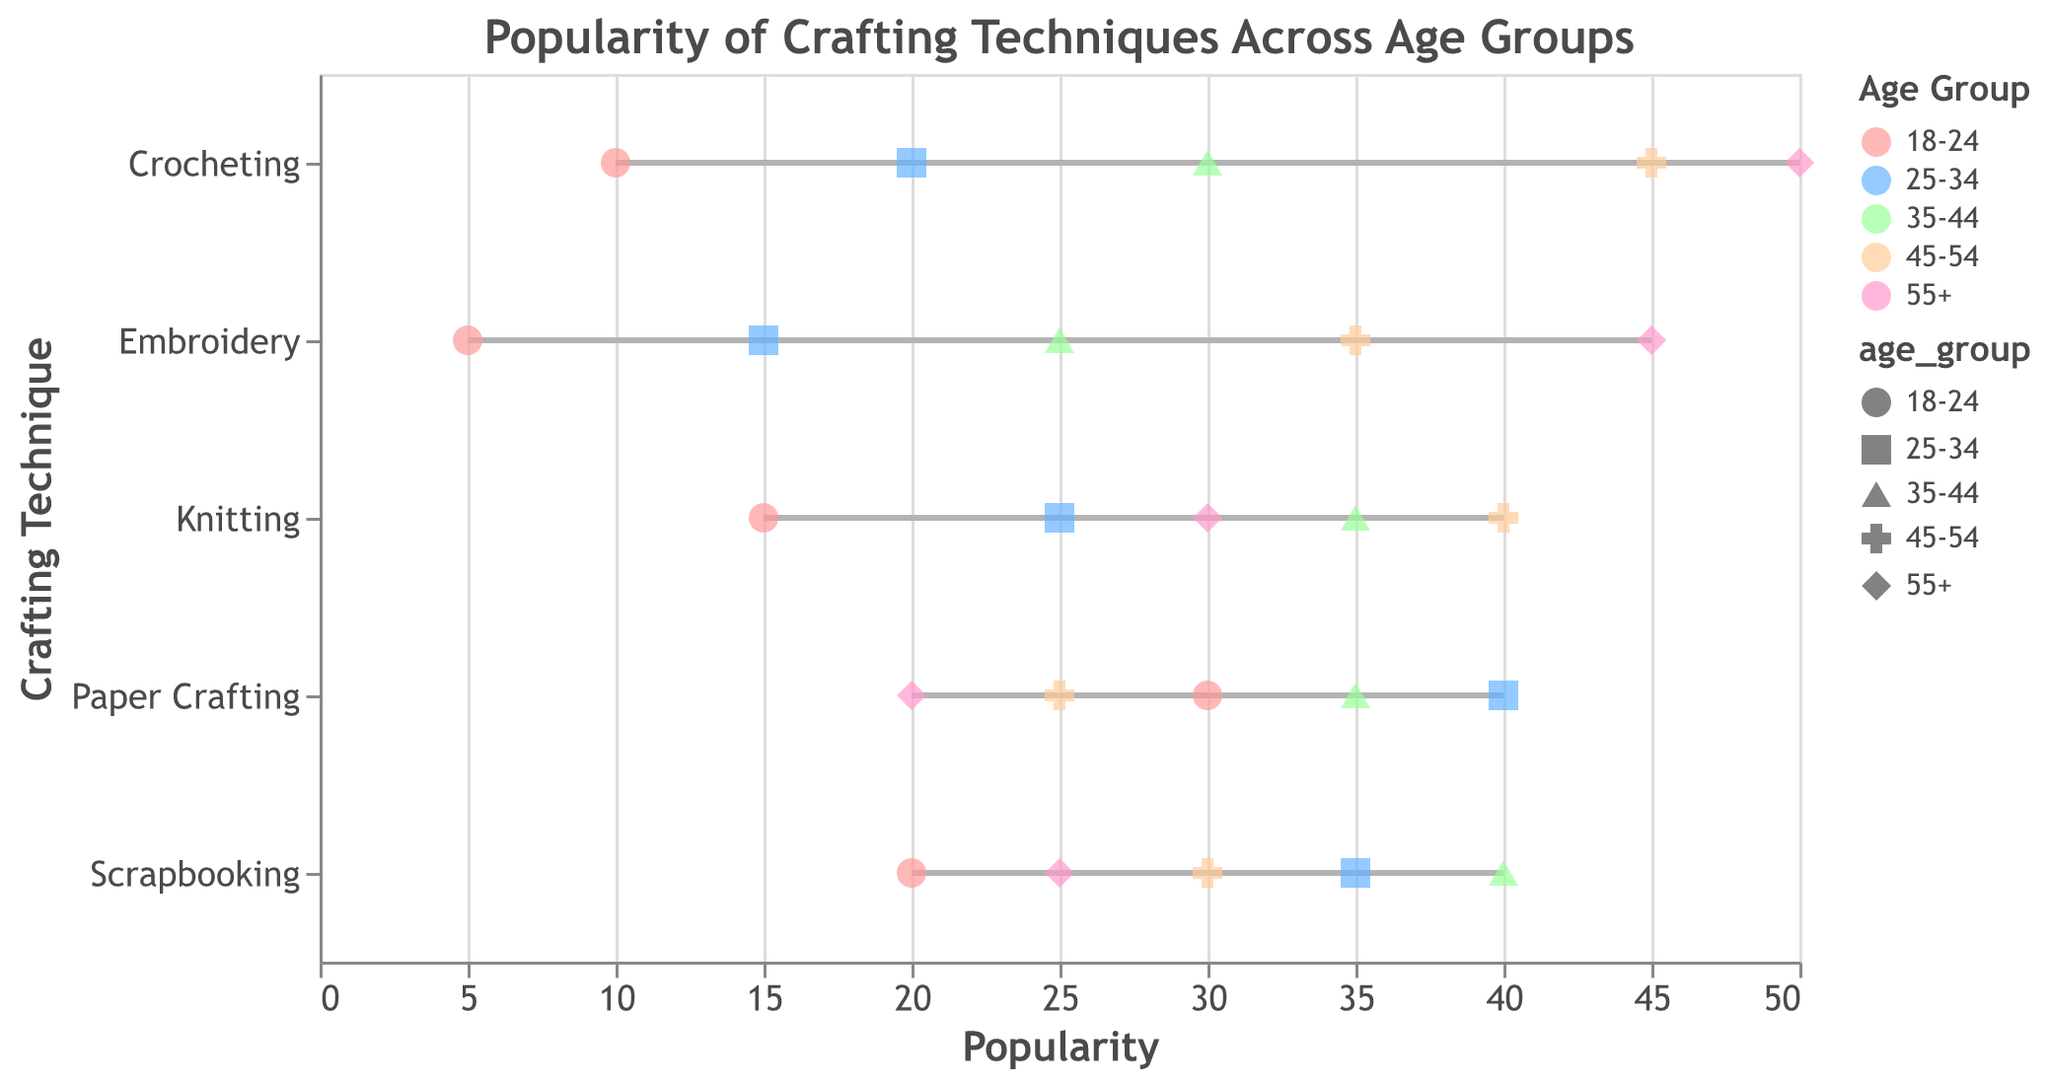What's the title of the plot? The title of the plot is usually located at the top. In this plot, it reads "Popularity of Crafting Techniques Across Age Groups."
Answer: Popularity of Crafting Techniques Across Age Groups What age group is represented by the color pink in the plot? Colors and corresponding age groups are typically noted in the legend section. Pink corresponds to the age group "55+".
Answer: 55+ Which crafting technique is most popular among the 18-24 age group? The 18-24 age group is represented by the pink points. Observing the y-axis for different techniques, the highest value for this age group is "Paper Crafting" at a popularity of 30.
Answer: Paper Crafting What is the average popularity of Crocheting across all age groups? Look at the popularity values for Crocheting across all age groups: 10, 20, 30, 45, and 50. The average is calculated as (10+20+30+45+50)/5 = 31.
Answer: 31 Does Scrapbooking or Embroidery have a higher popularity among the 35-44 age group? Refer to the 35-44 age group colors, and compare their position and values. Scrapbooking is at 40, while Embroidery is at 25. Therefore, Scrapbooking is higher.
Answer: Scrapbooking For which crafting technique does the 45-54 age group show the highest popularity? Examine the different techniques for the age group 45-54. The highest popularity of 45 is seen in both Crocheting and Embroidery.
Answer: Crocheting, Embroidery Which age group shows the lowest popularity for Knitting? Analyze the popularity for the technique of Knitting across all age groups. The lowest value is 15 for the 18-24 age group.
Answer: 18-24 Is Paper Crafting more popular among the 25-34 age group or the 45-54 age group? Look at the positions of Paper Crafting’s popularity in the 25-34 and 45-54 age groups. The 25-34 age group has a higher value of 40 compared to the 45-54 age group value of 25.
Answer: 25-34 What is the difference in popularity for Knitting between the 18-24 age group and the 45-54 age group? The values for Knitting in the 18-24 age group is 15, and in the 45-54 age group, it is 40. The difference is 40 - 15 = 25.
Answer: 25 Which crafting technique shows the least variation in popularity across age groups? Consider the range of popularity values for all age groups for each technique. The technique with the smallest difference between the highest and lowest values is Knitting with a range of 15-40 (25).
Answer: Knitting 